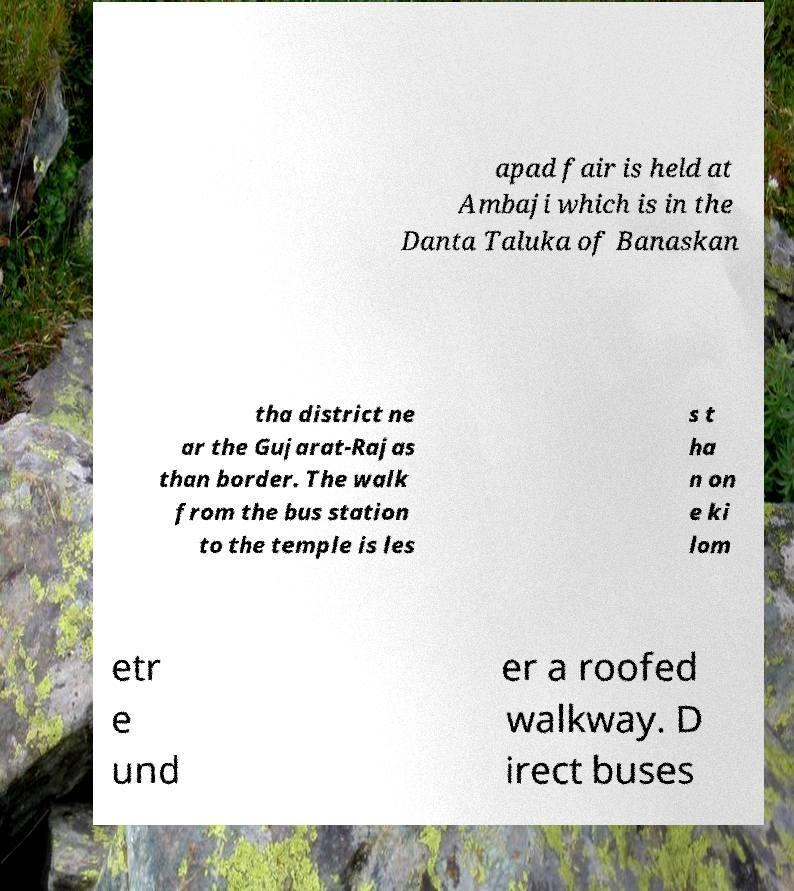I need the written content from this picture converted into text. Can you do that? apad fair is held at Ambaji which is in the Danta Taluka of Banaskan tha district ne ar the Gujarat-Rajas than border. The walk from the bus station to the temple is les s t ha n on e ki lom etr e und er a roofed walkway. D irect buses 